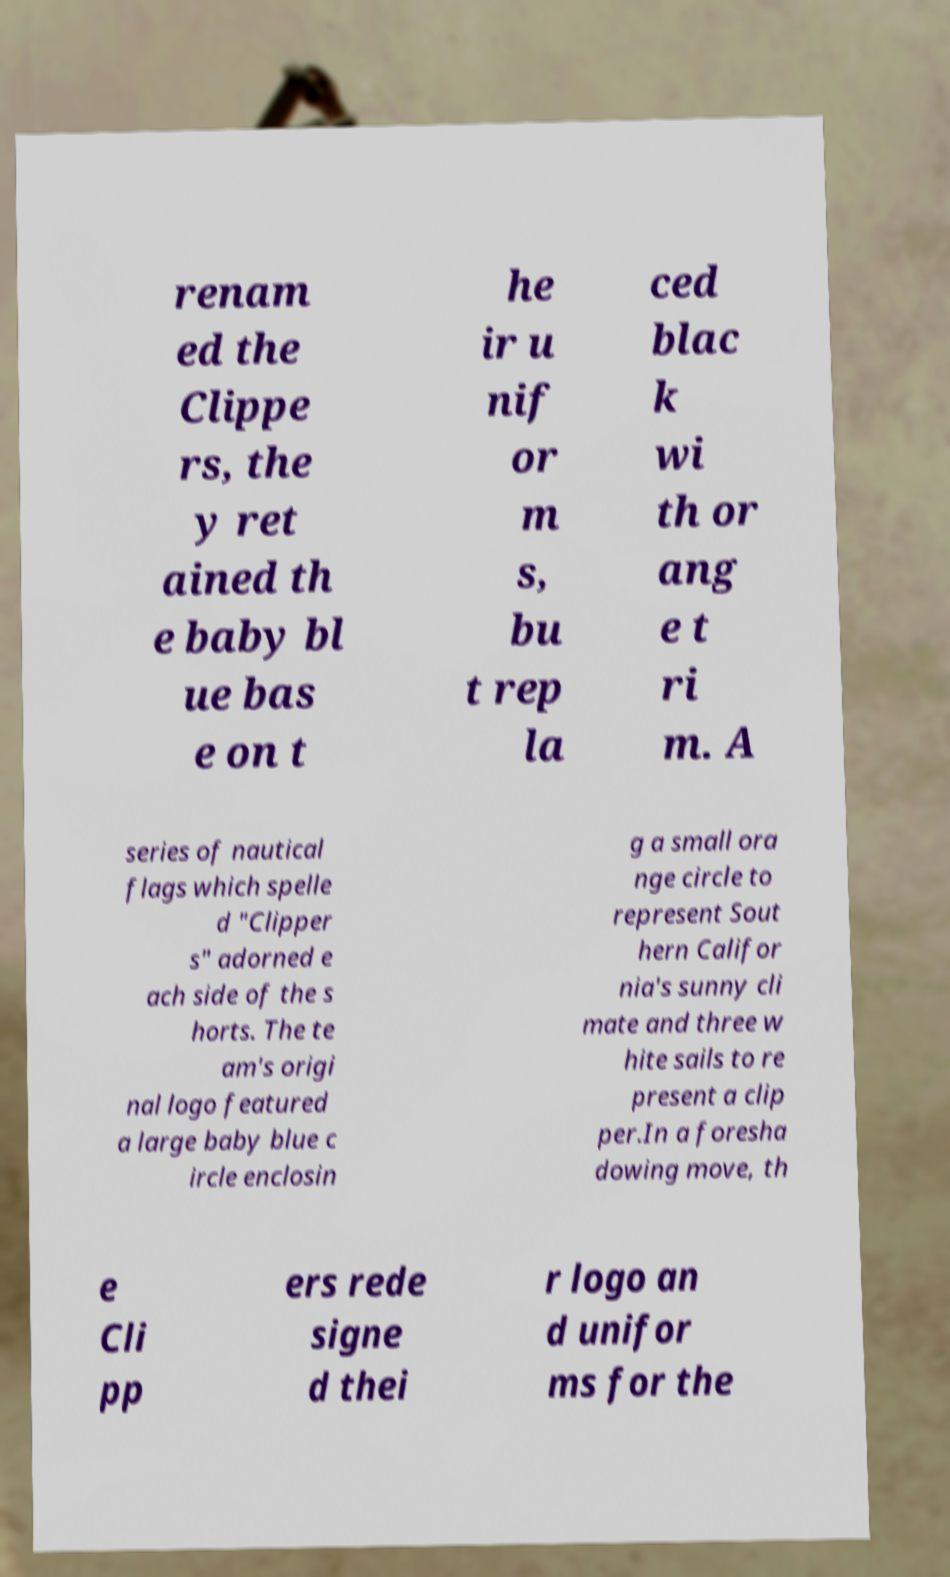I need the written content from this picture converted into text. Can you do that? renam ed the Clippe rs, the y ret ained th e baby bl ue bas e on t he ir u nif or m s, bu t rep la ced blac k wi th or ang e t ri m. A series of nautical flags which spelle d "Clipper s" adorned e ach side of the s horts. The te am's origi nal logo featured a large baby blue c ircle enclosin g a small ora nge circle to represent Sout hern Califor nia's sunny cli mate and three w hite sails to re present a clip per.In a foresha dowing move, th e Cli pp ers rede signe d thei r logo an d unifor ms for the 